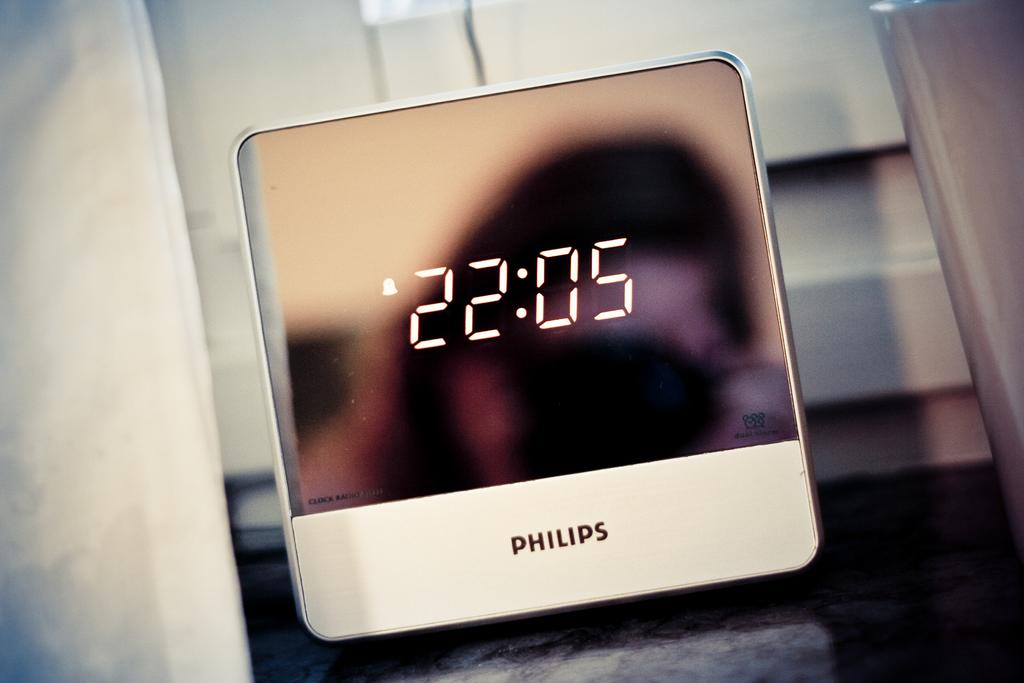What type of timepiece is visible in the image? There is a digital watch in the image. What brand is the digital watch? The watch has "Philips" written on it. Can you describe the background of the image? The background of the image is blurred. What type of stew is being prepared in the image? There is no stew present in the image; it features a digital watch with "Philips" written on it. What is the purpose of the digital watch in the image? The purpose of the digital watch is to tell time, but this question cannot be definitively answered without additional context. 